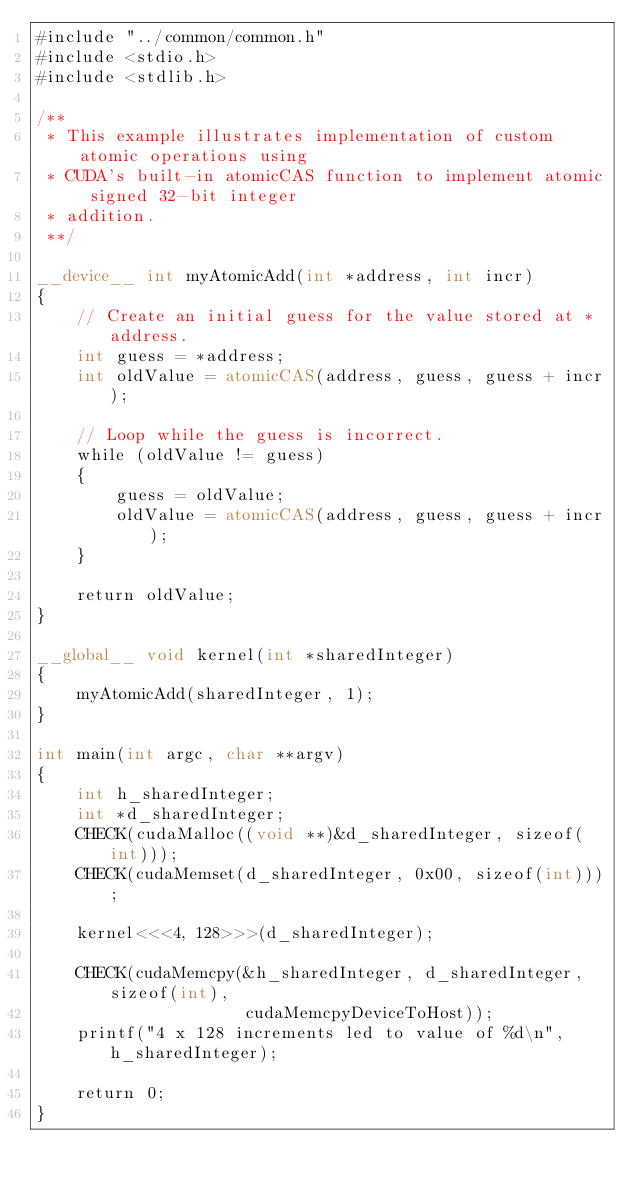Convert code to text. <code><loc_0><loc_0><loc_500><loc_500><_Cuda_>#include "../common/common.h"
#include <stdio.h>
#include <stdlib.h>

/**
 * This example illustrates implementation of custom atomic operations using
 * CUDA's built-in atomicCAS function to implement atomic signed 32-bit integer
 * addition.
 **/

__device__ int myAtomicAdd(int *address, int incr)
{
    // Create an initial guess for the value stored at *address.
    int guess = *address;
    int oldValue = atomicCAS(address, guess, guess + incr);

    // Loop while the guess is incorrect.
    while (oldValue != guess)
    {
        guess = oldValue;
        oldValue = atomicCAS(address, guess, guess + incr);
    }

    return oldValue;
}

__global__ void kernel(int *sharedInteger)
{
    myAtomicAdd(sharedInteger, 1);
}

int main(int argc, char **argv)
{
    int h_sharedInteger;
    int *d_sharedInteger;
    CHECK(cudaMalloc((void **)&d_sharedInteger, sizeof(int)));
    CHECK(cudaMemset(d_sharedInteger, 0x00, sizeof(int)));

    kernel<<<4, 128>>>(d_sharedInteger);

    CHECK(cudaMemcpy(&h_sharedInteger, d_sharedInteger, sizeof(int),
                     cudaMemcpyDeviceToHost));
    printf("4 x 128 increments led to value of %d\n", h_sharedInteger);

    return 0;
}

</code> 